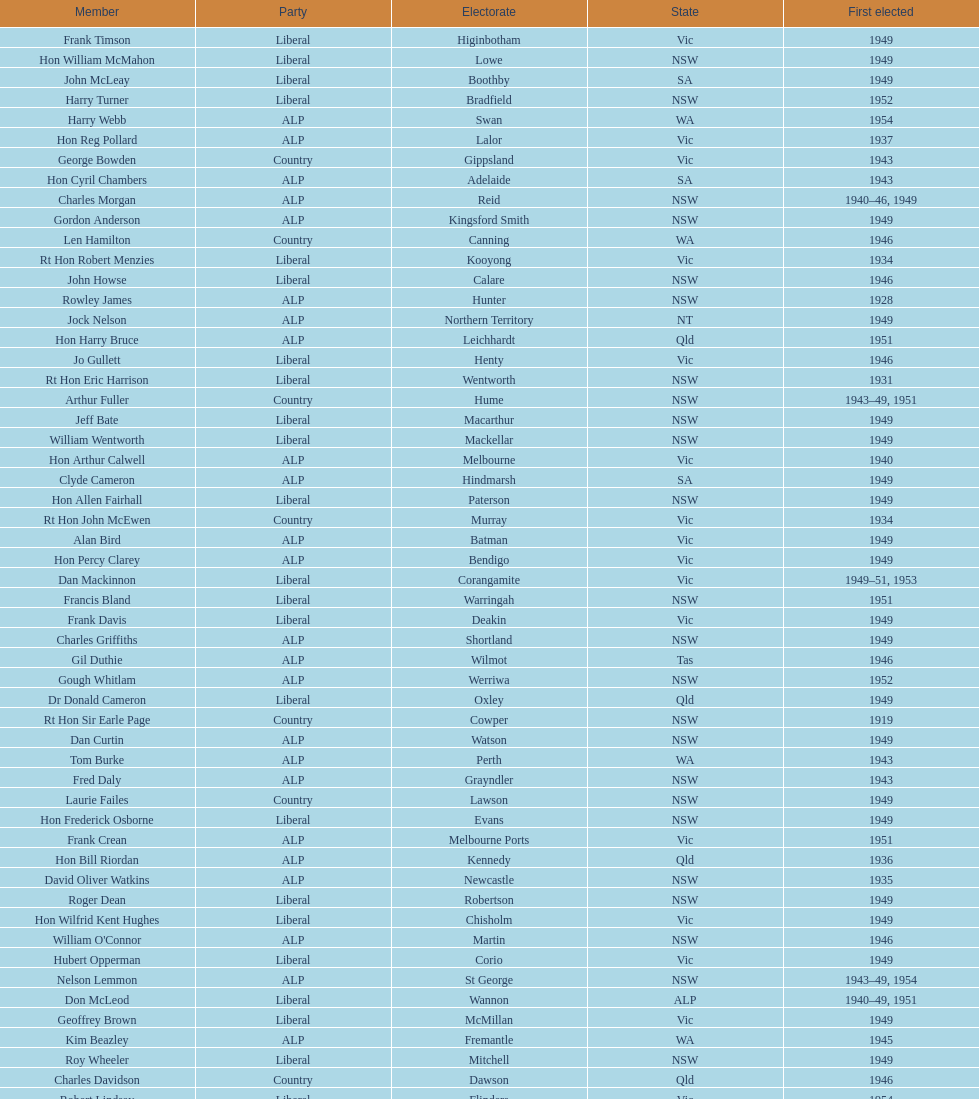Did tom burke run as country or alp party? ALP. 